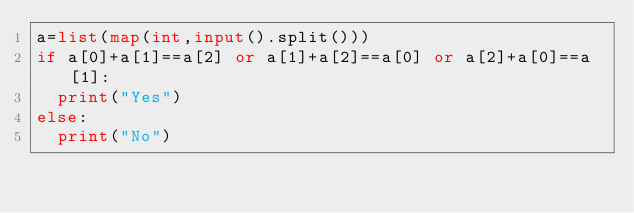<code> <loc_0><loc_0><loc_500><loc_500><_Python_>a=list(map(int,input().split()))
if a[0]+a[1]==a[2] or a[1]+a[2]==a[0] or a[2]+a[0]==a[1]:
  print("Yes")
else:
  print("No")</code> 